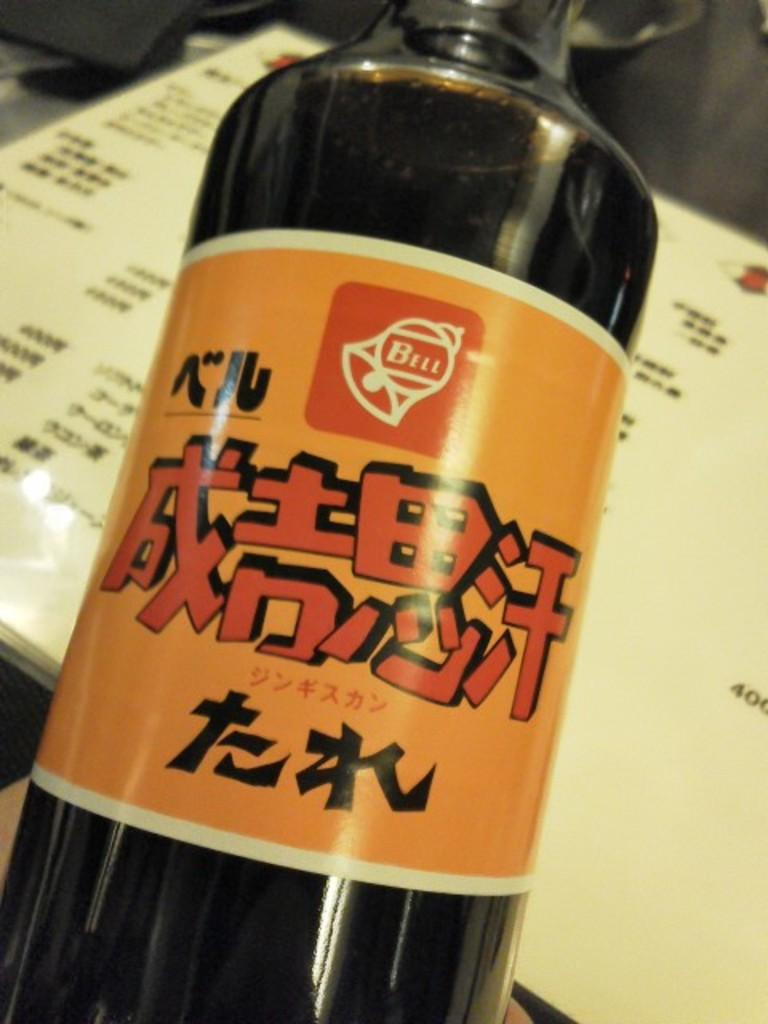<image>
Write a terse but informative summary of the picture. A bottle of liquid with the word bell on it. 